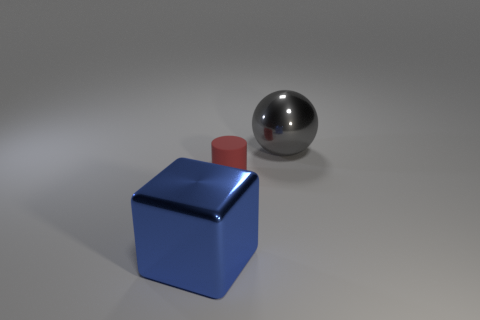Is there anything else that has the same size as the red thing?
Provide a short and direct response. No. There is a gray metal ball; is it the same size as the metal thing in front of the gray metallic sphere?
Ensure brevity in your answer.  Yes. What is the red thing in front of the large shiny ball made of?
Provide a succinct answer. Rubber. What number of things are on the left side of the gray object and right of the blue shiny cube?
Provide a short and direct response. 1. There is a blue block that is the same size as the gray metallic object; what material is it?
Provide a succinct answer. Metal. Does the thing behind the small red thing have the same size as the metallic thing that is on the left side of the small matte cylinder?
Give a very brief answer. Yes. Are there any small things to the left of the red rubber object?
Make the answer very short. No. There is a metal thing that is in front of the big object that is behind the small object; what color is it?
Your answer should be compact. Blue. Is the number of large cyan matte objects less than the number of blue blocks?
Provide a short and direct response. Yes. There is a object that is the same size as the blue block; what is its color?
Your response must be concise. Gray. 